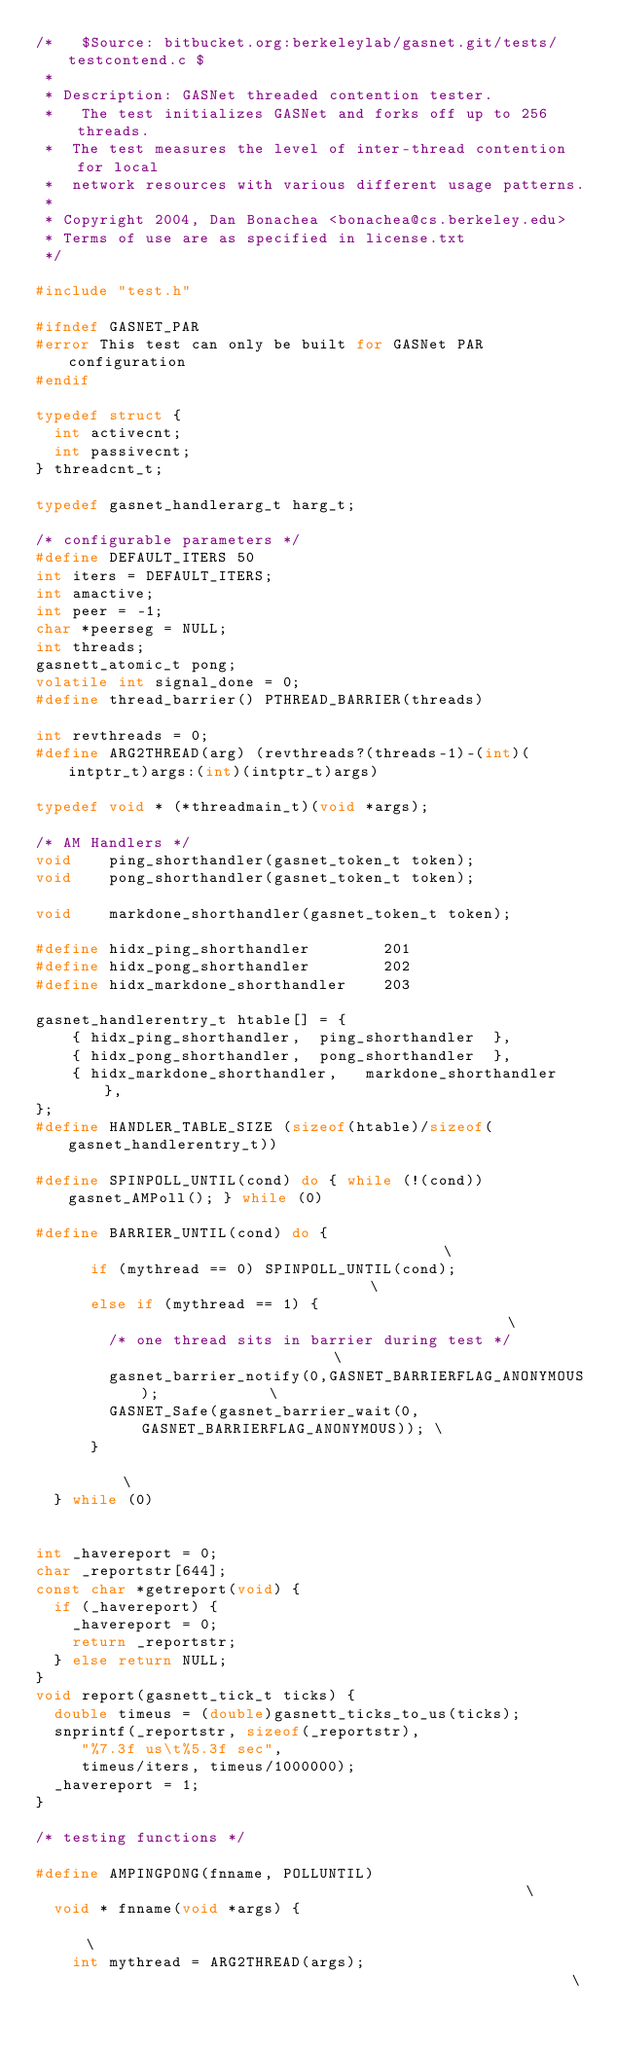<code> <loc_0><loc_0><loc_500><loc_500><_C_>/*   $Source: bitbucket.org:berkeleylab/gasnet.git/tests/testcontend.c $
 *
 * Description: GASNet threaded contention tester.
 *   The test initializes GASNet and forks off up to 256 threads.  
 *  The test measures the level of inter-thread contention for local 
 *  network resources with various different usage patterns.
 *
 * Copyright 2004, Dan Bonachea <bonachea@cs.berkeley.edu>
 * Terms of use are as specified in license.txt
 */

#include "test.h"

#ifndef GASNET_PAR
#error This test can only be built for GASNet PAR configuration
#endif

typedef struct {
  int activecnt;
  int passivecnt;
} threadcnt_t;

typedef gasnet_handlerarg_t harg_t;

/* configurable parameters */
#define DEFAULT_ITERS 50
int	iters = DEFAULT_ITERS;
int amactive;
int peer = -1;
char *peerseg = NULL;
int threads;
gasnett_atomic_t pong;
volatile int signal_done = 0;
#define thread_barrier() PTHREAD_BARRIER(threads)

int revthreads = 0;
#define ARG2THREAD(arg) (revthreads?(threads-1)-(int)(intptr_t)args:(int)(intptr_t)args)

typedef void * (*threadmain_t)(void *args);

/* AM Handlers */
void	ping_shorthandler(gasnet_token_t token);
void 	pong_shorthandler(gasnet_token_t token);

void	markdone_shorthandler(gasnet_token_t token);

#define hidx_ping_shorthandler        201
#define hidx_pong_shorthandler        202
#define hidx_markdone_shorthandler    203

gasnet_handlerentry_t htable[] = { 
	{ hidx_ping_shorthandler,  ping_shorthandler  },
	{ hidx_pong_shorthandler,  pong_shorthandler  },
	{ hidx_markdone_shorthandler,   markdone_shorthandler   },
};
#define HANDLER_TABLE_SIZE (sizeof(htable)/sizeof(gasnet_handlerentry_t))

#define SPINPOLL_UNTIL(cond) do { while (!(cond)) gasnet_AMPoll(); } while (0)

#define BARRIER_UNTIL(cond) do {                                          \
      if (mythread == 0) SPINPOLL_UNTIL(cond);                            \
      else if (mythread == 1) {                                           \
        /* one thread sits in barrier during test */                      \
        gasnet_barrier_notify(0,GASNET_BARRIERFLAG_ANONYMOUS);            \
        GASNET_Safe(gasnet_barrier_wait(0,GASNET_BARRIERFLAG_ANONYMOUS)); \
      }                                                                   \
  } while (0)

    
int _havereport = 0;
char _reportstr[644];
const char *getreport(void) {
  if (_havereport) {
    _havereport = 0;
    return _reportstr;
  } else return NULL;
}
void report(gasnett_tick_t ticks) {
  double timeus = (double)gasnett_ticks_to_us(ticks);
  snprintf(_reportstr, sizeof(_reportstr),
     "%7.3f us\t%5.3f sec", 
     timeus/iters, timeus/1000000);
  _havereport = 1;
}

/* testing functions */

#define AMPINGPONG(fnname, POLLUNTIL)                                                   \
  void * fnname(void *args) {                                                           \
    int mythread = ARG2THREAD(args);                                                    \</code> 